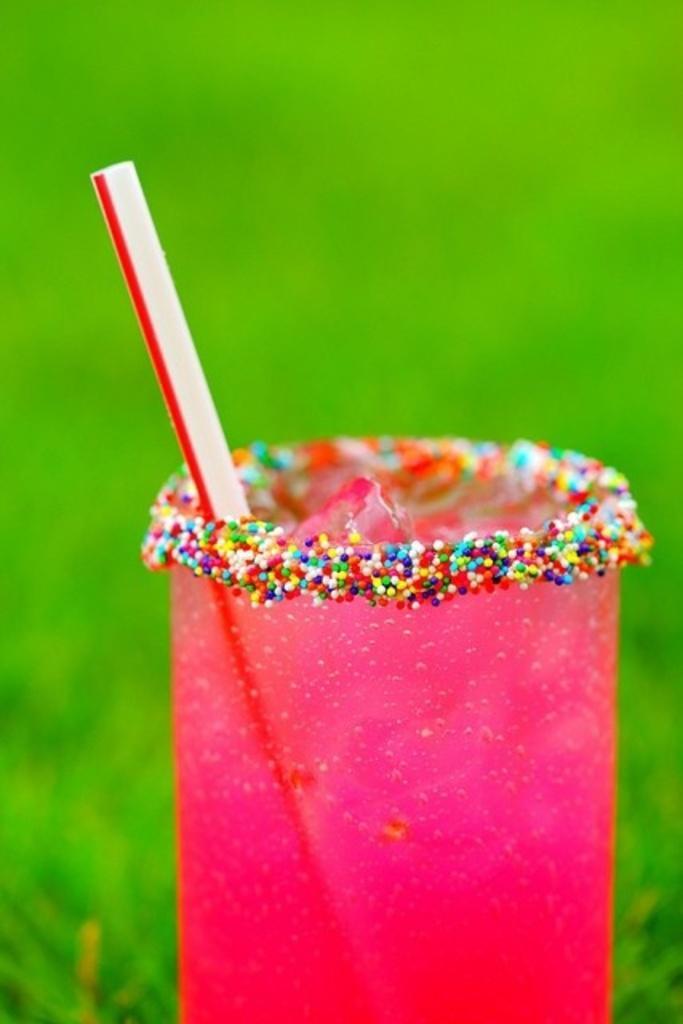In one or two sentences, can you explain what this image depicts? In this image, in the middle, we can see a glass which is in pink color, in the glass, we can see a straw. In the background, we can see green color. 